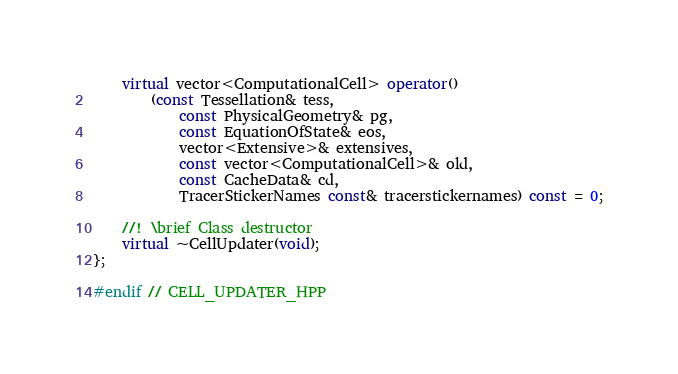Convert code to text. <code><loc_0><loc_0><loc_500><loc_500><_C++_>	virtual vector<ComputationalCell> operator()
		(const Tessellation& tess,
			const PhysicalGeometry& pg,
			const EquationOfState& eos,
			vector<Extensive>& extensives,
			const vector<ComputationalCell>& old,
			const CacheData& cd,
			TracerStickerNames const& tracerstickernames) const = 0;

	//! \brief Class destructor
	virtual ~CellUpdater(void);
};

#endif // CELL_UPDATER_HPP
</code> 